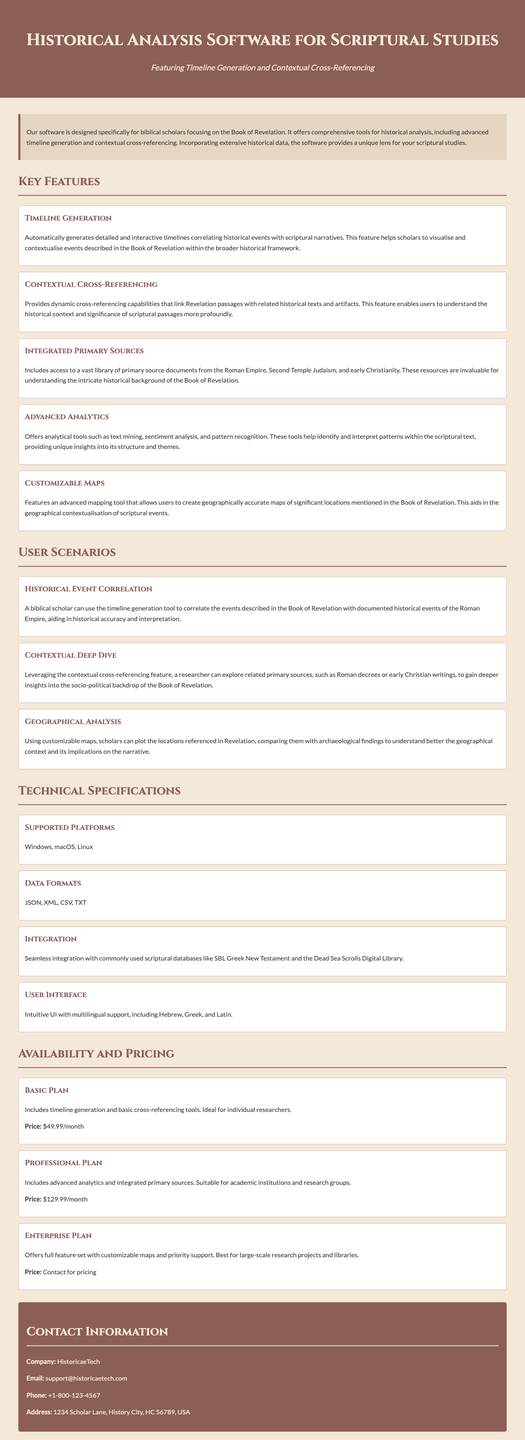What is the primary focus of the software? The software is designed specifically for biblical scholars focusing on the Book of Revelation.
Answer: Book of Revelation What feature helps in visualizing historical events? The document mentions a specific feature that correlates historical events with scriptural narratives.
Answer: Timeline Generation What is included in the Professional Plan? The Professional Plan offers advanced features that are detailed in the document.
Answer: Advanced analytics and integrated primary sources What data formats does the software support? The specifications section lists the compatible data formats for the software.
Answer: JSON, XML, CSV, TXT What type of mapping tool does the software offer? The features section describes the capability of the mapping tool.
Answer: Customizable Maps What is the price of the Basic Plan? The availability and pricing section specifies the monthly cost of the Basic Plan.
Answer: $49.99/month How can users contact the company for support? The document provides contact information for the company.
Answer: support@historicaetech.com In which environments can the software operate? The technical specifications section details the platforms that support the software.
Answer: Windows, macOS, Linux What type of users would benefit from the Enterprise Plan? The document outlines the suitability of the Enterprise Plan.
Answer: Large-scale research projects and libraries 